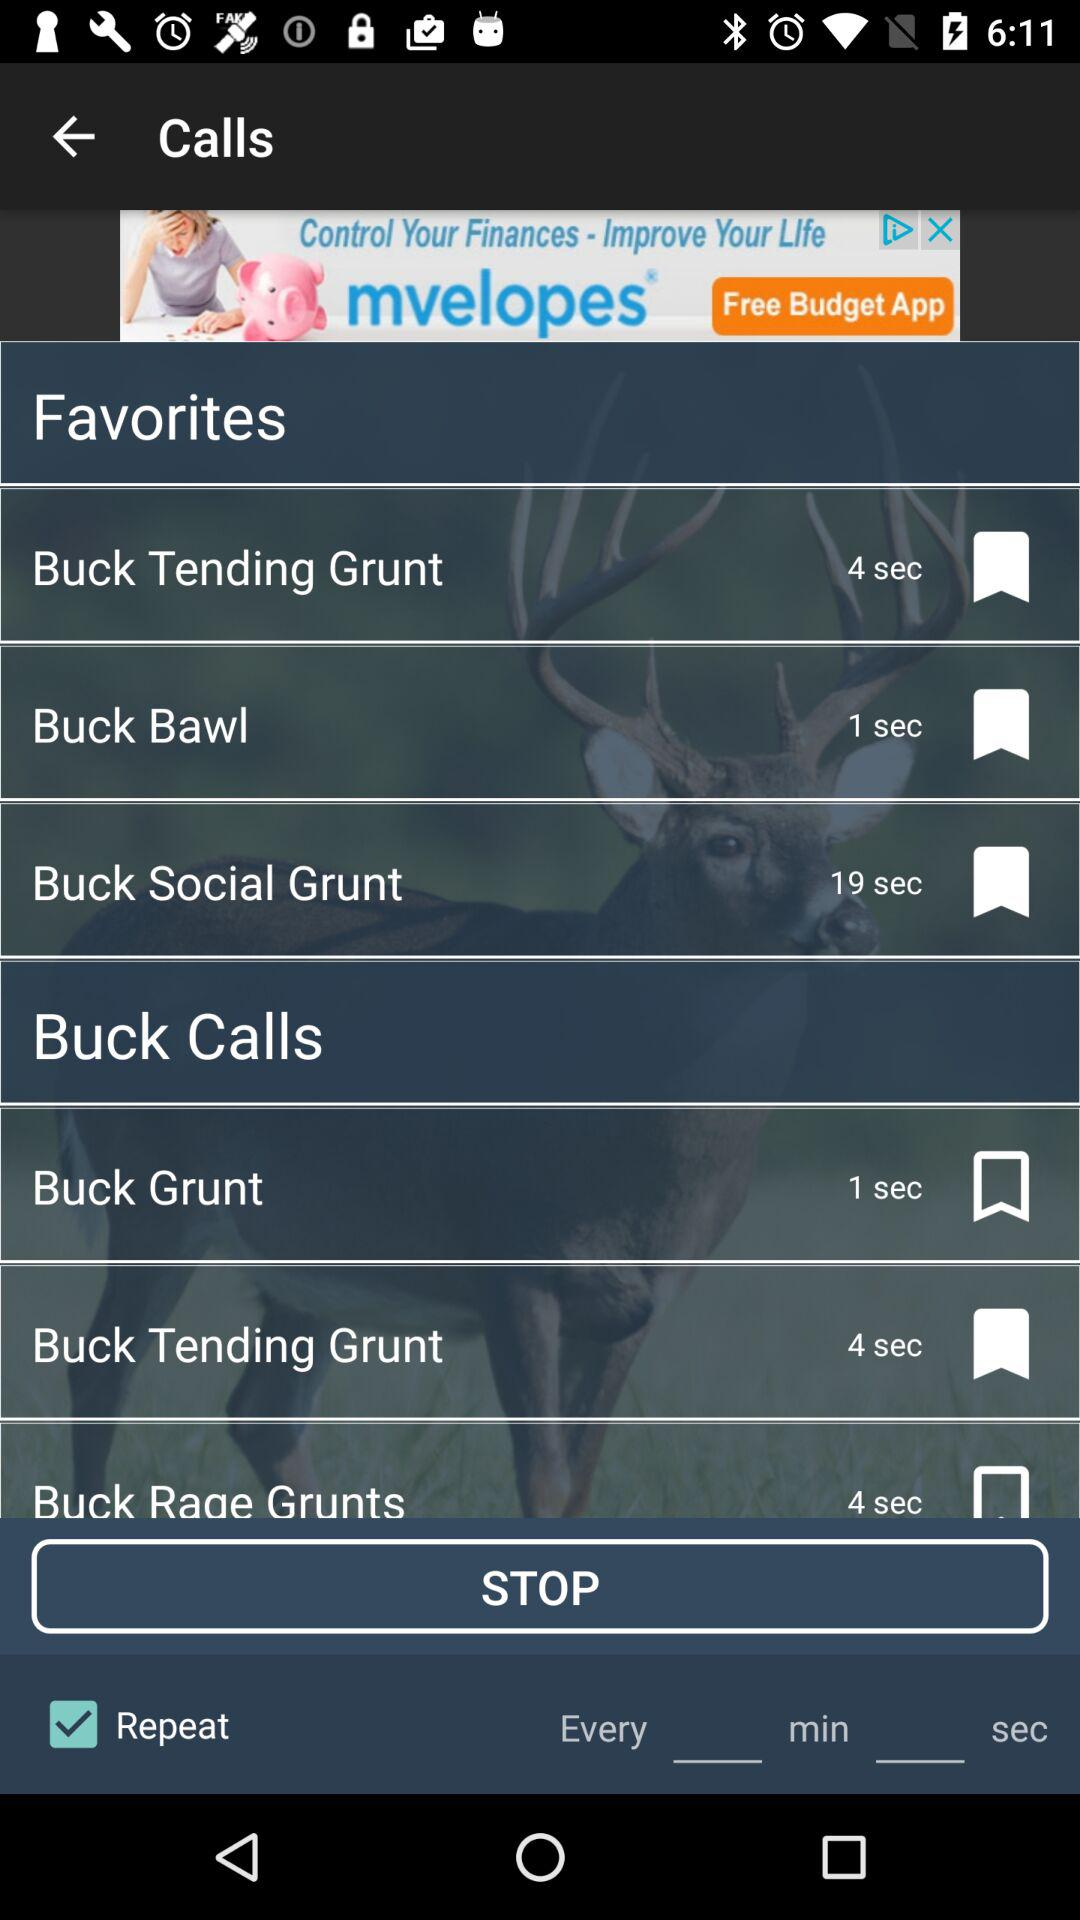What is the call duration of "Buck Bawl"? The call duration is 1 second. 